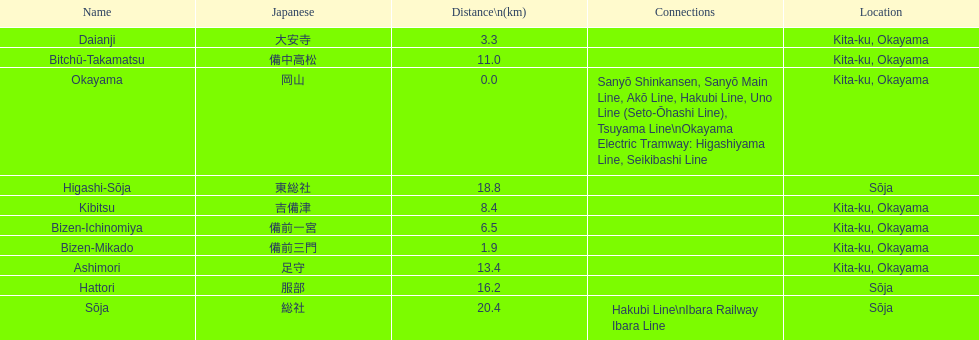Which has a distance of more than 1 kilometer but less than 2 kilometers? Bizen-Mikado. 